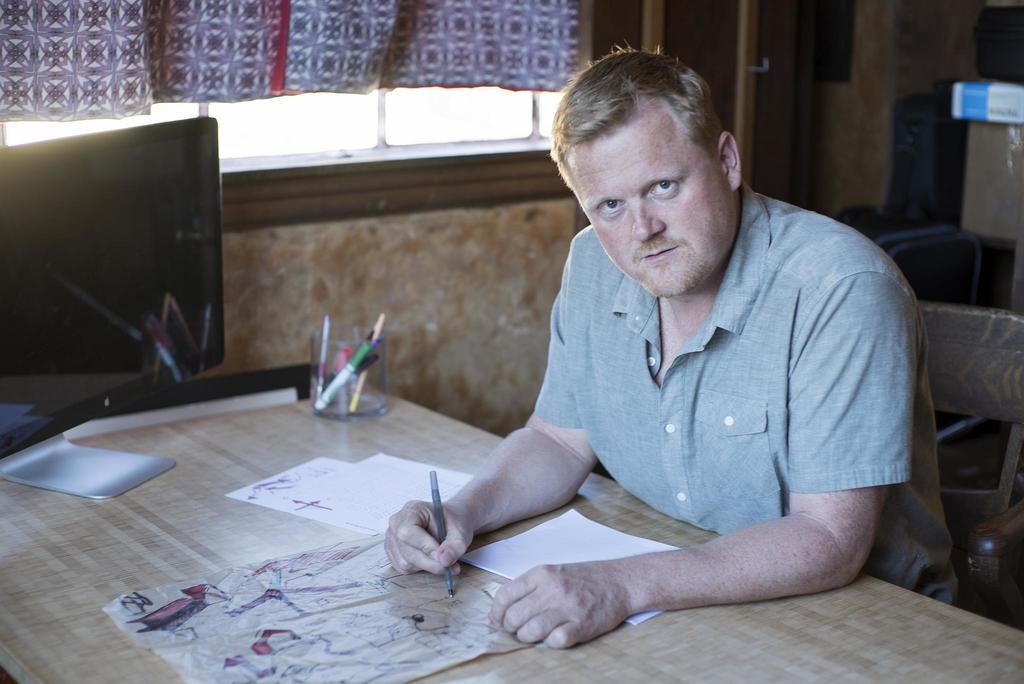Please provide a concise description of this image. This is a picture taken in a room, the man is sitting in the chair and writing on the paper. This is a table on the table there are the papers and a bowl in bowl there are pens. Background of the person is a wall and windows with a curtain. 